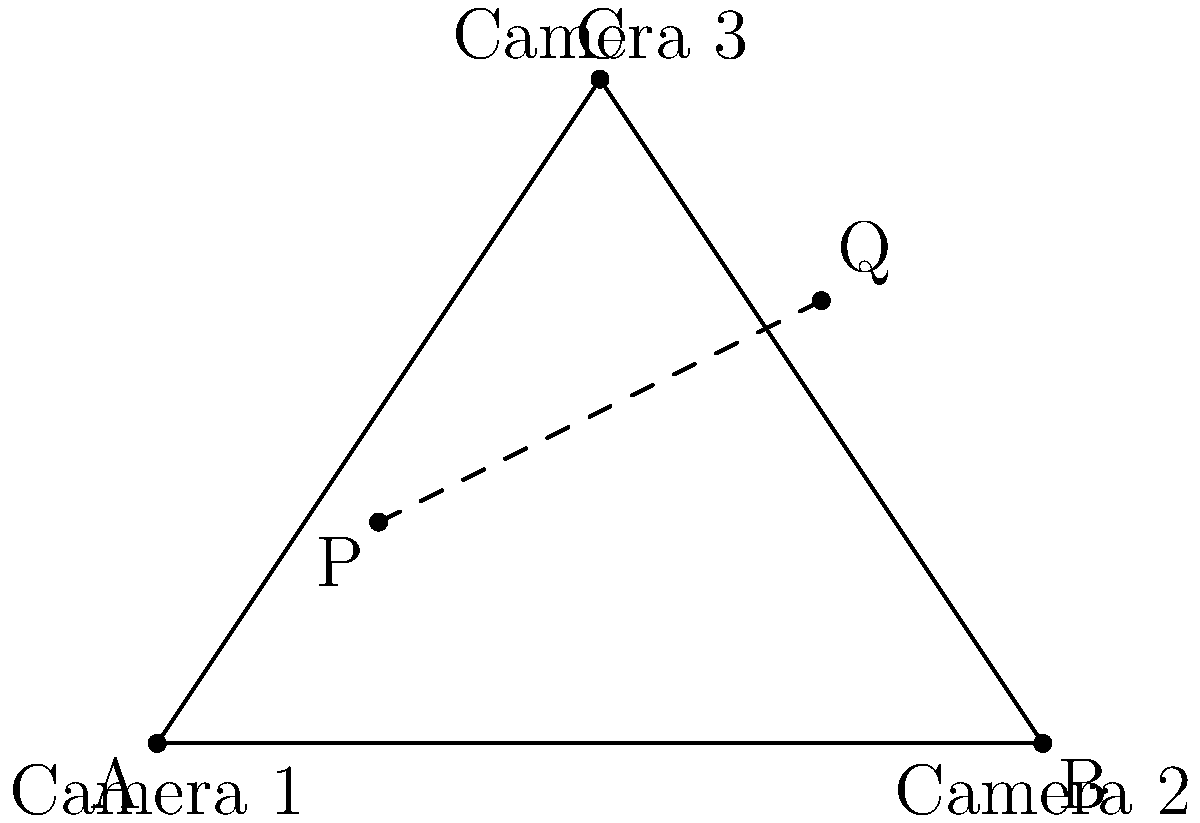In a multi-camera network setup for object tracking, three cameras are positioned at points A(0,0), B(4,0), and C(2,3) in a local coordinate system. An object is detected by Camera 1 at point P(1,1) and by Camera 2 at point Q(3,2) in their respective local coordinate frames. Assuming the cameras have been calibrated to the unified coordinate system represented by the triangle ABC, what is the equation of the line PQ in this unified system? To find the equation of line PQ in the unified coordinate system, we'll follow these steps:

1) First, we need to verify that points P and Q are already in the unified coordinate system. Since they are given in relation to the triangle ABC, we can assume they are.

2) To find the equation of a line, we need two things:
   a) The slope of the line
   b) A point on the line

3) Let's calculate the slope:
   Slope = $m = \frac{y_2 - y_1}{x_2 - x_1} = \frac{2 - 1}{3 - 1} = \frac{1}{2}$

4) Now we have the slope and two points. We can use the point-slope form of a line:
   $y - y_1 = m(x - x_1)$

5) Let's use point P(1,1):
   $y - 1 = \frac{1}{2}(x - 1)$

6) Expand this equation:
   $y - 1 = \frac{1}{2}x - \frac{1}{2}$

7) Rearrange to slope-intercept form $(y = mx + b)$:
   $y = \frac{1}{2}x - \frac{1}{2} + 1$
   $y = \frac{1}{2}x + \frac{1}{2}$

Therefore, the equation of line PQ in the unified coordinate system is $y = \frac{1}{2}x + \frac{1}{2}$.
Answer: $y = \frac{1}{2}x + \frac{1}{2}$ 